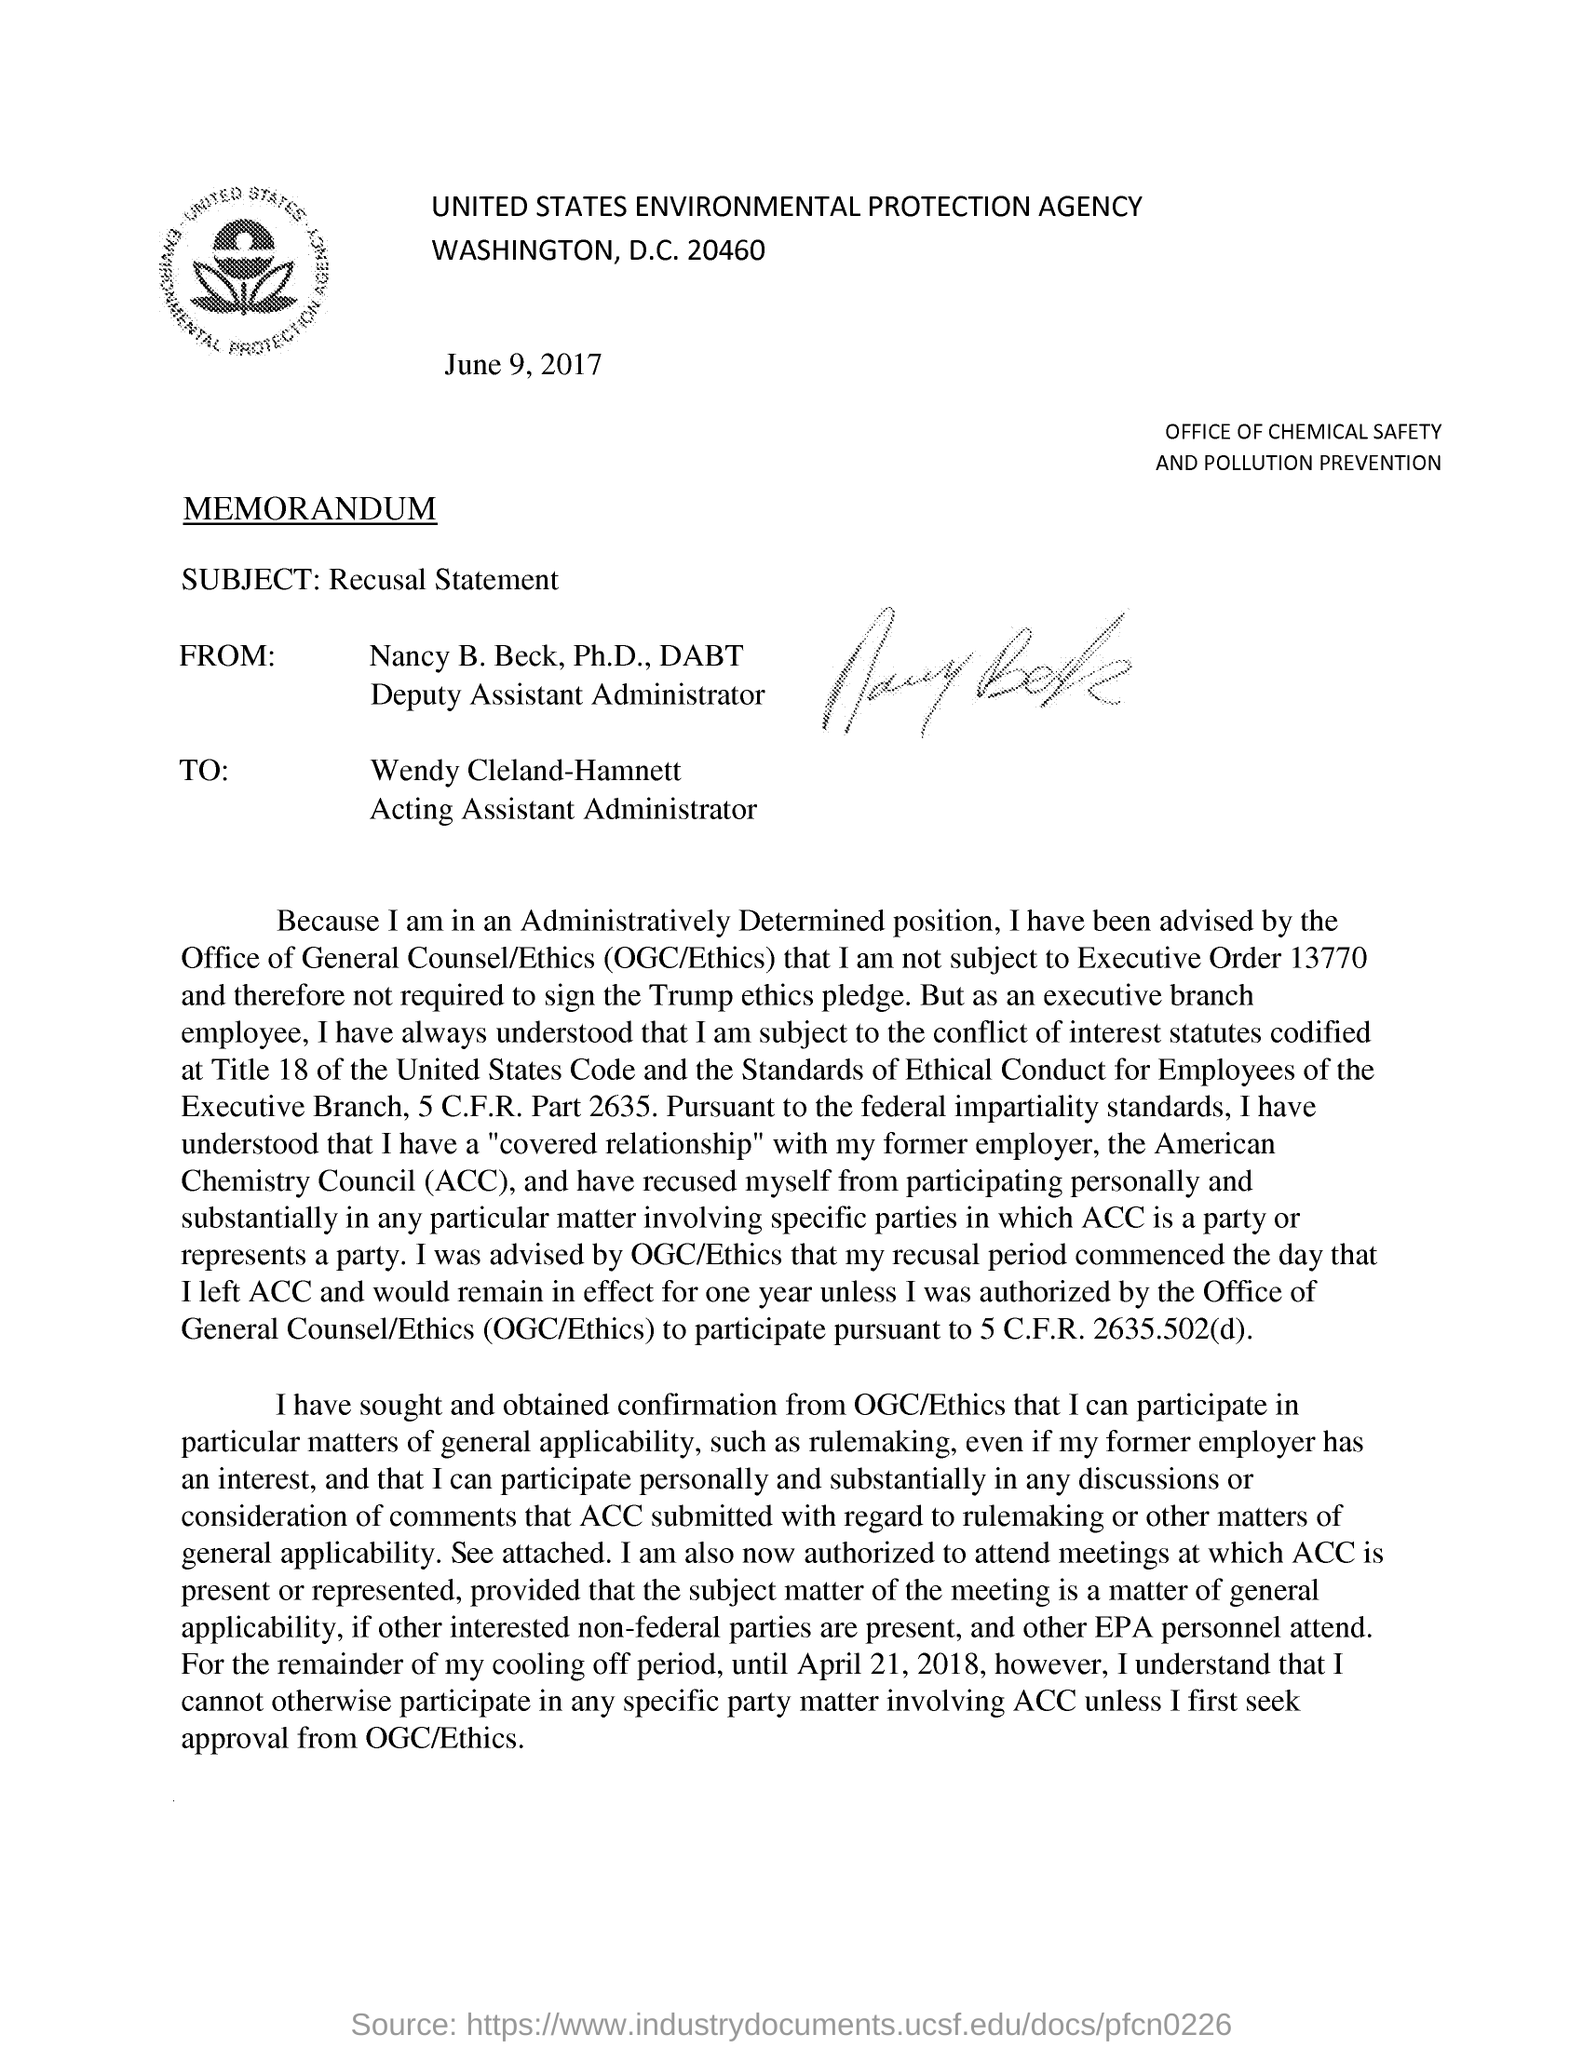By whom is this document written?
Ensure brevity in your answer.  Nancy B. Beck. What is the date mentioned?
Make the answer very short. June 9, 2017. To whom is this document addressed?
Make the answer very short. Wendy Cleland-Hamnett. What is the subject of the memorandum?
Make the answer very short. Recusal Statement. 